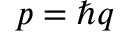Convert formula to latex. <formula><loc_0><loc_0><loc_500><loc_500>p = \hbar { q }</formula> 